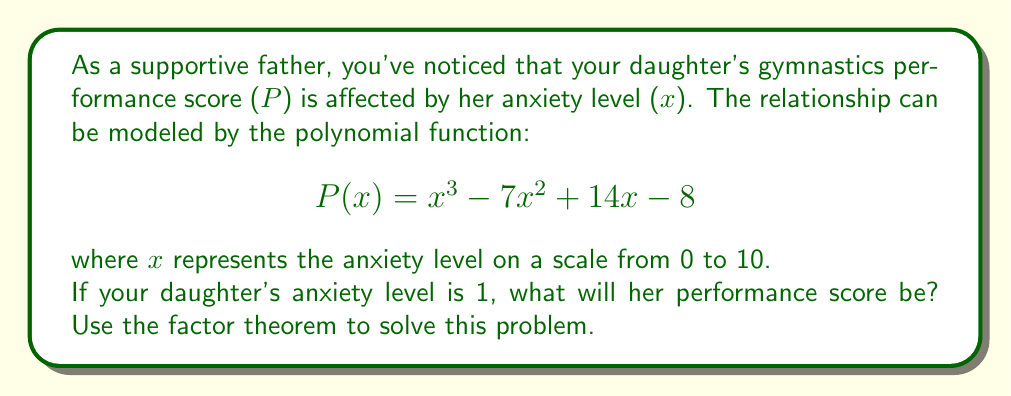Can you solve this math problem? To solve this problem using the factor theorem, we'll follow these steps:

1) The factor theorem states that if $f(a) = 0$, then $(x - a)$ is a factor of $f(x)$.

2) In this case, we want to find $P(1)$, so we'll substitute $x = 1$ into the polynomial:

   $$P(1) = (1)^3 - 7(1)^2 + 14(1) - 8$$

3) Let's calculate this step by step:
   
   $$P(1) = 1 - 7 + 14 - 8$$
   $$P(1) = 15 - 15 = 0$$

4) Since $P(1) = 0$, according to the factor theorem, $(x - 1)$ is a factor of $P(x)$.

5) This means we can factor the polynomial as:

   $$P(x) = (x - 1)(ax^2 + bx + c)$$

   where $a$, $b$, and $c$ are constants we need to determine.

6) However, for the purpose of this question, we don't need to complete the factorization. The fact that $P(1) = 0$ is sufficient to answer the question.

7) Interpreting this result in the context of the problem:
   When the anxiety level (x) is 1, the performance score P(1) is 0.

This mathematical model suggests that a very low level of anxiety (1 on a scale of 0 to 10) results in the lowest possible performance score. In reality, this might represent the idea that a small amount of anxiety or excitement can actually be beneficial for performance, while the absence of any anxiety (x = 0) or too much anxiety (x > 1) could lead to suboptimal performance.
Answer: When your daughter's anxiety level is 1, her performance score will be 0. 